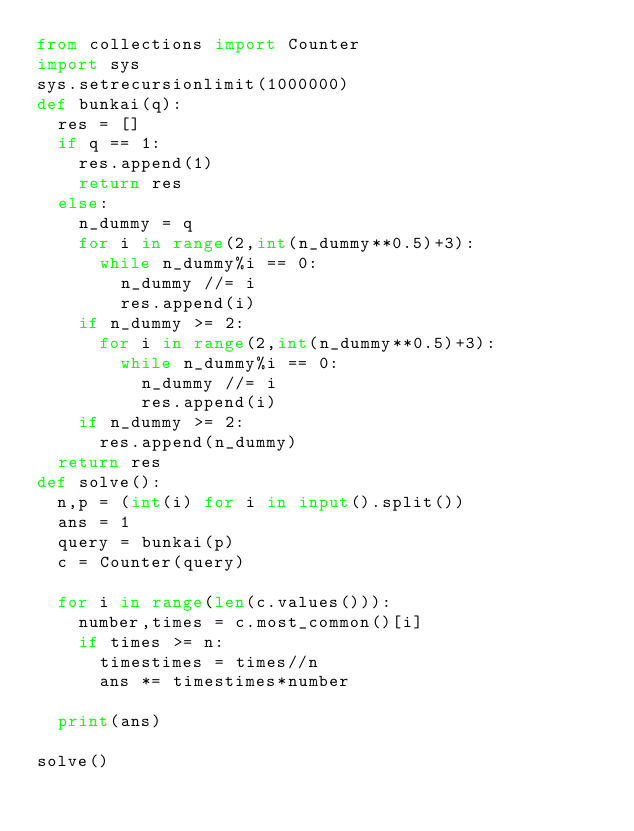Convert code to text. <code><loc_0><loc_0><loc_500><loc_500><_Python_>from collections import Counter
import sys
sys.setrecursionlimit(1000000)
def bunkai(q):
  res = []
  if q == 1:
    res.append(1)
    return res
  else:
    n_dummy = q
    for i in range(2,int(n_dummy**0.5)+3):
      while n_dummy%i == 0:
        n_dummy //= i
        res.append(i)
    if n_dummy >= 2:
      for i in range(2,int(n_dummy**0.5)+3):
        while n_dummy%i == 0:
          n_dummy //= i
          res.append(i)
    if n_dummy >= 2:
      res.append(n_dummy)
  return res
def solve():
  n,p = (int(i) for i in input().split())
  ans = 1
  query = bunkai(p)
  c = Counter(query)
  
  for i in range(len(c.values())):
    number,times = c.most_common()[i]
    if times >= n:
      timestimes = times//n
      ans *= timestimes*number

  print(ans)
  
solve()</code> 